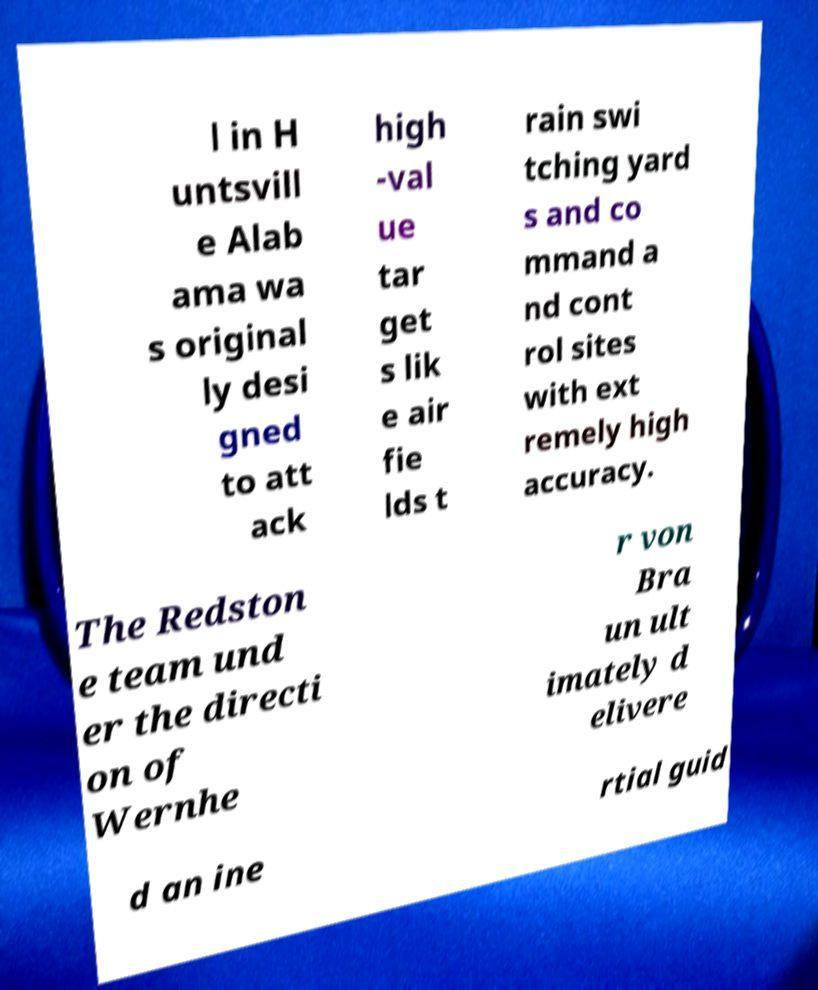I need the written content from this picture converted into text. Can you do that? l in H untsvill e Alab ama wa s original ly desi gned to att ack high -val ue tar get s lik e air fie lds t rain swi tching yard s and co mmand a nd cont rol sites with ext remely high accuracy. The Redston e team und er the directi on of Wernhe r von Bra un ult imately d elivere d an ine rtial guid 